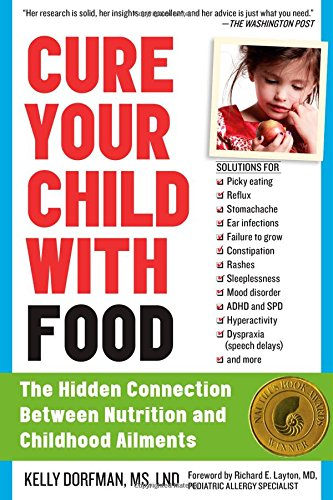Who is the author of this book? The author of this book, as featured on the cover, is Kelly Dorfman. She is known for her expertise in the field of nutrition and its impacts on children's health. 